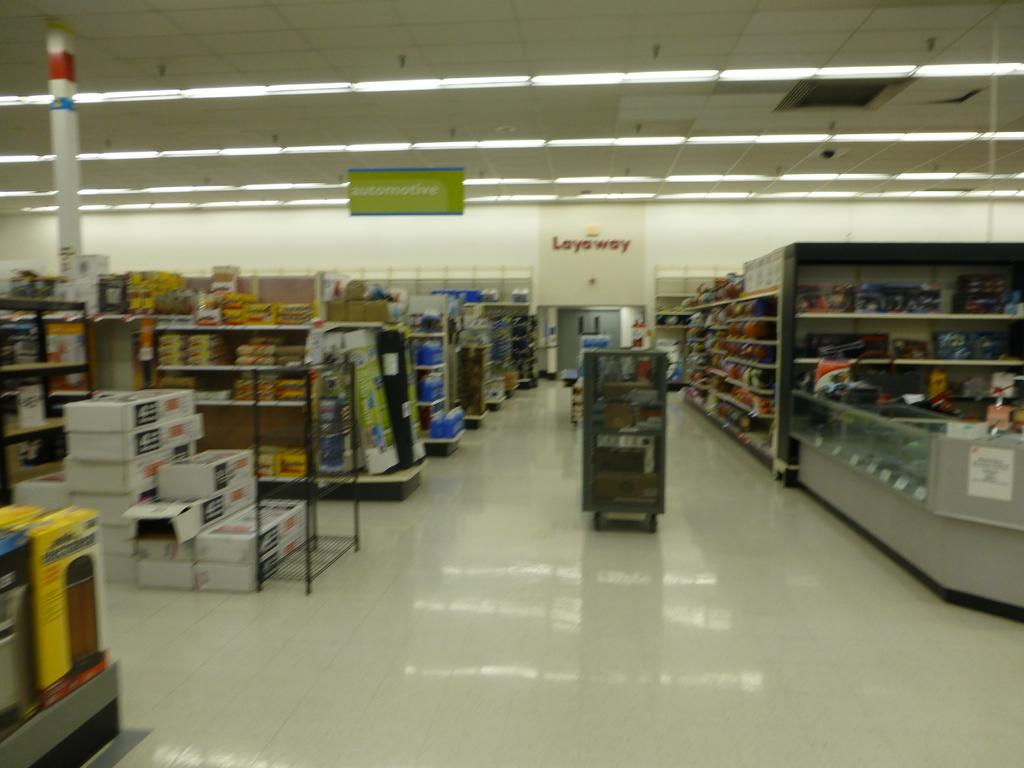What type of establishment is depicted in the image? The image appears to depict a grocery shop. What can be seen on the racks in the image? There is stock on the right side and the left side of the image on the racks. What is providing illumination in the image? There are lights at the top side of the image. What type of meat is being sold in the morning in the image? There is no meat or indication of time (morning) present in the image. 